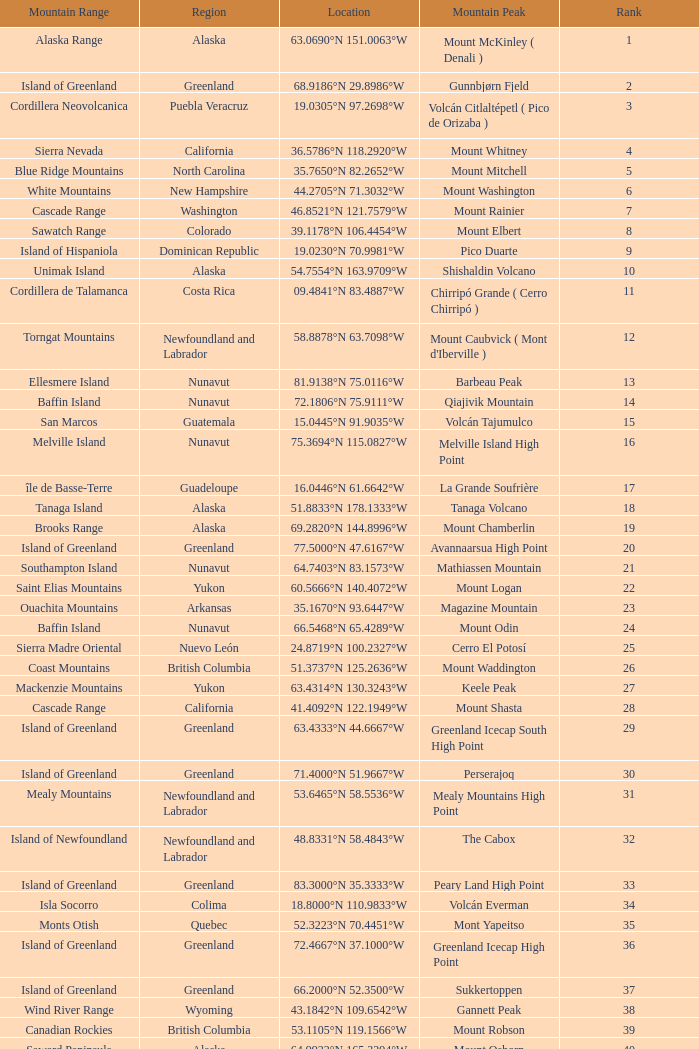Which Mountain Range has a Region of haiti, and a Location of 18.3601°n 71.9764°w? Island of Hispaniola. 